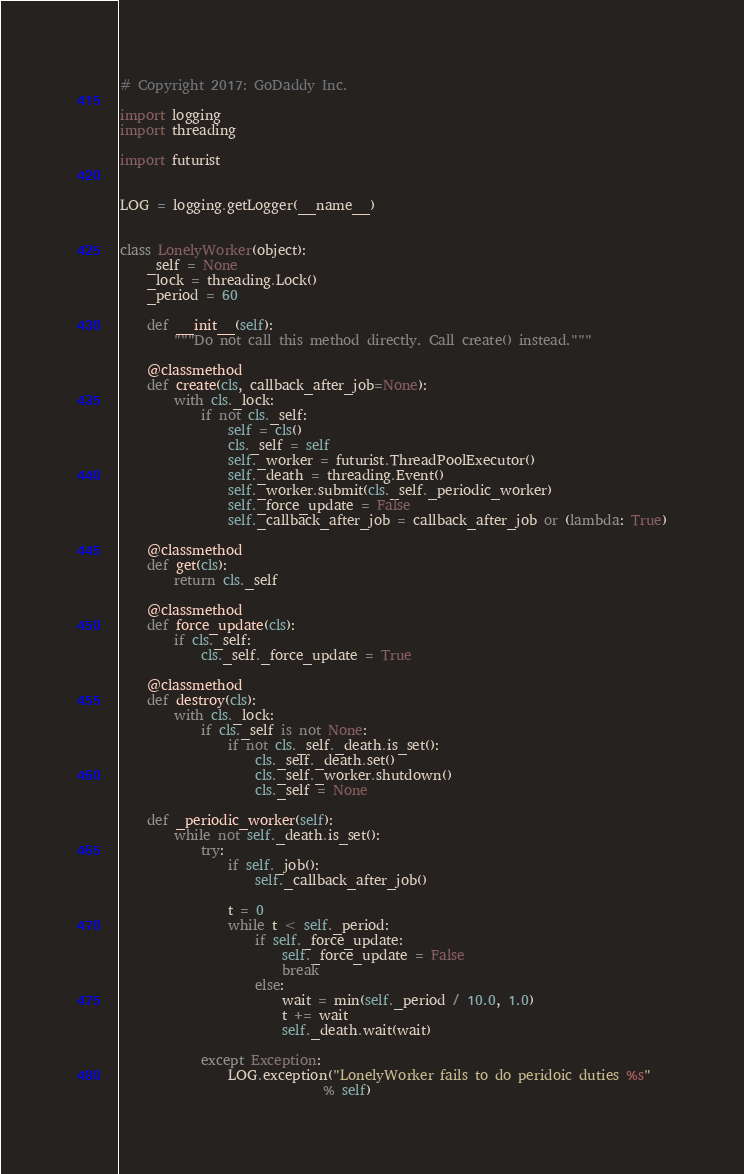<code> <loc_0><loc_0><loc_500><loc_500><_Python_># Copyright 2017: GoDaddy Inc.

import logging
import threading

import futurist


LOG = logging.getLogger(__name__)


class LonelyWorker(object):
    _self = None
    _lock = threading.Lock()
    _period = 60

    def __init__(self):
        """Do not call this method directly. Call create() instead."""

    @classmethod
    def create(cls, callback_after_job=None):
        with cls._lock:
            if not cls._self:
                self = cls()
                cls._self = self
                self._worker = futurist.ThreadPoolExecutor()
                self._death = threading.Event()
                self._worker.submit(cls._self._periodic_worker)
                self._force_update = False
                self._callback_after_job = callback_after_job or (lambda: True)

    @classmethod
    def get(cls):
        return cls._self

    @classmethod
    def force_update(cls):
        if cls._self:
            cls._self._force_update = True

    @classmethod
    def destroy(cls):
        with cls._lock:
            if cls._self is not None:
                if not cls._self._death.is_set():
                    cls._self._death.set()
                    cls._self._worker.shutdown()
                    cls._self = None

    def _periodic_worker(self):
        while not self._death.is_set():
            try:
                if self._job():
                    self._callback_after_job()

                t = 0
                while t < self._period:
                    if self._force_update:
                        self._force_update = False
                        break
                    else:
                        wait = min(self._period / 10.0, 1.0)
                        t += wait
                        self._death.wait(wait)

            except Exception:
                LOG.exception("LonelyWorker fails to do peridoic duties %s"
                              % self)
</code> 